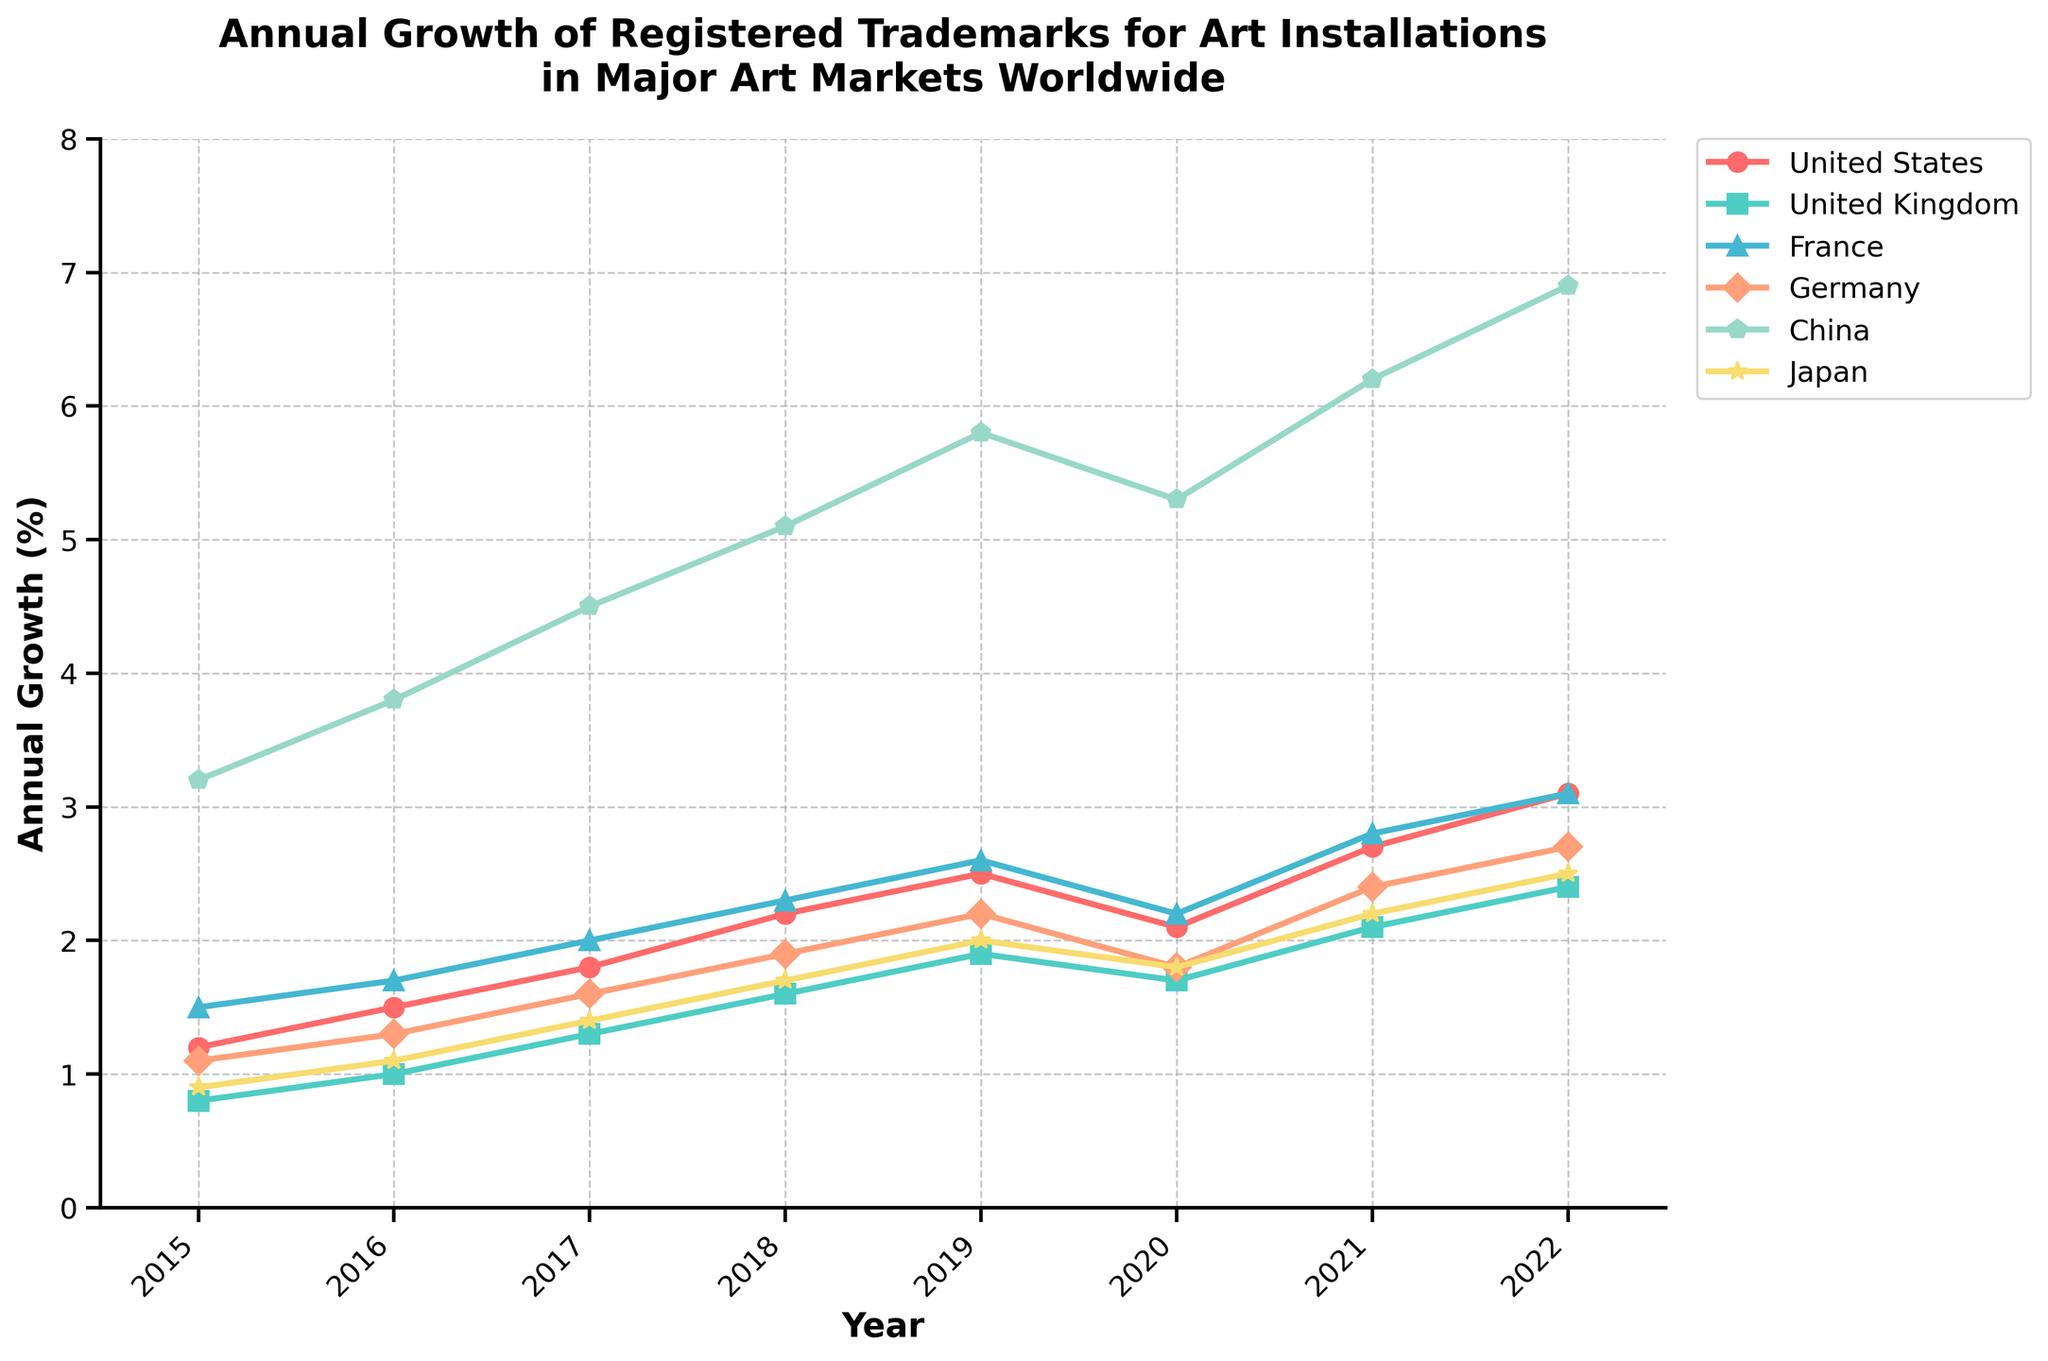What is the trend in annual growth of registered trademarks for art installations in China from 2015 to 2022? The trend in annual growth of registered trademarks for art installations in China is consistently upward, starting at 3.2% in 2015 and reaching 6.9% in 2022, except for a slight dip in 2020.
Answer: Upward trend Which country had the highest annual growth of registered trademarks for art installations in 2022? In 2022, the country with the highest annual growth of registered trademarks for art installations was China, with a growth rate of 6.9%.
Answer: China Compare the growth in registered trademarks between the United States and Japan in 2018. Which one had a higher growth rate? In 2018, the United States had an annual growth rate of 2.2%, while Japan had a growth rate of 1.7%. Therefore, the United States had a higher growth rate than Japan.
Answer: United States What was the average annual growth rate for registered trademarks in France from 2015 to 2022? To find the average annual growth rate for France from 2015 to 2022, sum the annual growth rates (1.5, 1.7, 2.0, 2.3, 2.6, 2.2, 2.8, 3.1) and divide by the number of years (8). The total is 18.2, so the average is 18.2/8.
Answer: 2.275% Identify the year with the lowest growth rate for art installations in the United Kingdom. The year with the lowest growth rate for art installations in the United Kingdom is 2015, with a growth rate of 0.8%.
Answer: 2015 How did the registered trademark growth rate in Germany change from 2019 to 2020? The registered trademark growth rate in Germany decreased from 2.2% in 2019 to 1.8% in 2020.
Answer: Decreased Which year showed a decrease in the growth rate for registered trademarks in all countries listed? In 2020, all countries listed (United States, United Kingdom, France, Germany, China, Japan) showed a decrease in the growth rate for registered trademarks.
Answer: 2020 What is the difference in annual growth rate between China and the United States in 2022? In 2022, China's annual growth rate was 6.9% and the United States' was 3.1%. The difference is 6.9% - 3.1%.
Answer: 3.8% Which country had the most consistent growth rate from 2015 to 2022? France had the most consistent growth rate from 2015 to 2022, with annual growth rates gradually increasing or remaining relatively stable.
Answer: France In which country did the annual growth rate double from 2015 to 2022? The annual growth rate for registered trademarks in the United States more than doubled from 1.2% in 2015 to 3.1% in 2022.
Answer: United States 